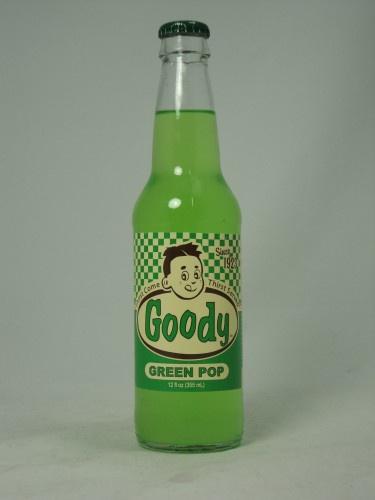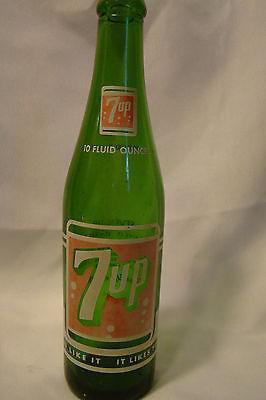The first image is the image on the left, the second image is the image on the right. Assess this claim about the two images: "The bottle in the image on the left has a white number on the label.". Correct or not? Answer yes or no. No. The first image is the image on the left, the second image is the image on the right. Evaluate the accuracy of this statement regarding the images: "There are two bottles, one glass and one plastic.". Is it true? Answer yes or no. No. 